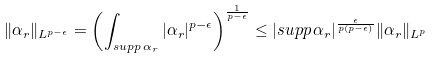<formula> <loc_0><loc_0><loc_500><loc_500>\| \alpha _ { r } \| _ { L ^ { p - \epsilon } } = \left ( \int _ { s u p p \, \alpha _ { r } } | \alpha _ { r } | ^ { p - \epsilon } \right ) ^ { \frac { 1 } { p - \epsilon } } \leq | s u p p \, \alpha _ { r } | ^ { \frac { \epsilon } { p ( p - \epsilon ) } } \| \alpha _ { r } \| _ { L ^ { p } }</formula> 